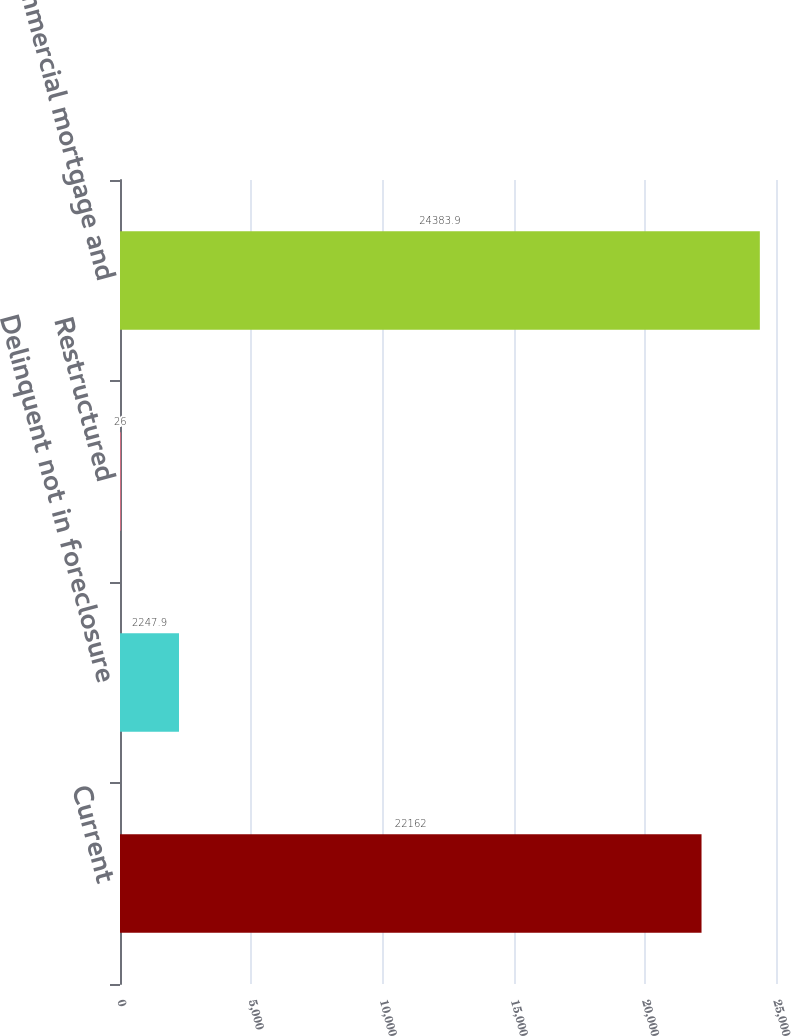Convert chart. <chart><loc_0><loc_0><loc_500><loc_500><bar_chart><fcel>Current<fcel>Delinquent not in foreclosure<fcel>Restructured<fcel>Total commercial mortgage and<nl><fcel>22162<fcel>2247.9<fcel>26<fcel>24383.9<nl></chart> 